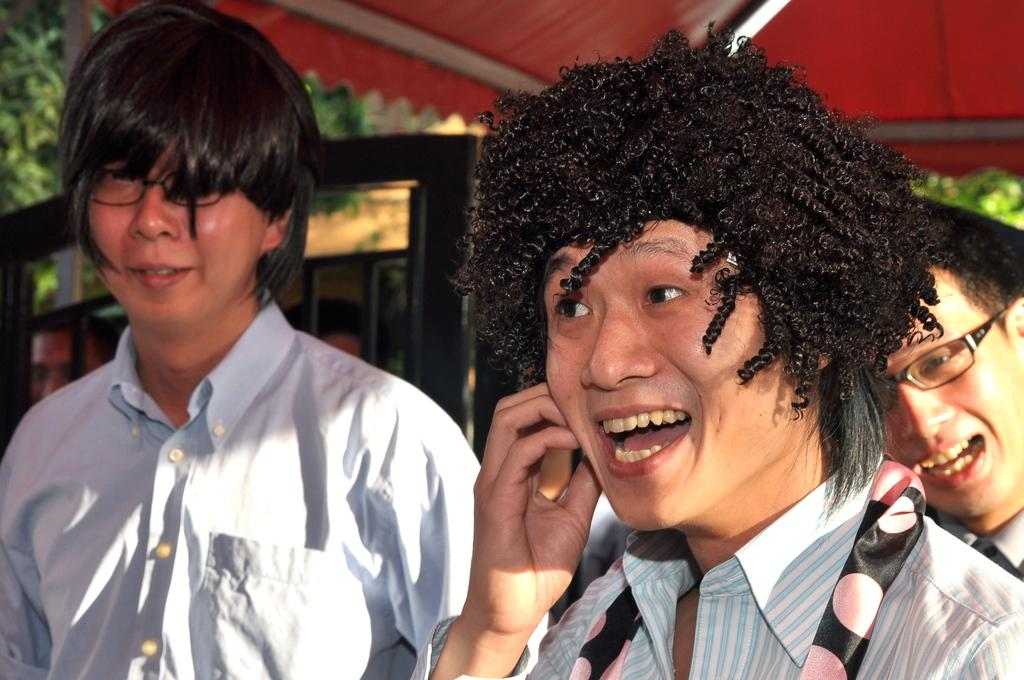How many people are in the image? There are three persons in the image. Where are the persons located in the image? The persons are at the bottom of the image. What can be seen in the background of the image? There are objects in the background of the image. What is visible at the top of the image? The roof is visible at the top of the image. Are there any dinosaurs visible in the image? No, there are no dinosaurs present in the image. What type of umbrella is being used by one of the persons in the image? There is no umbrella visible in the image; only the persons and their location are mentioned. 